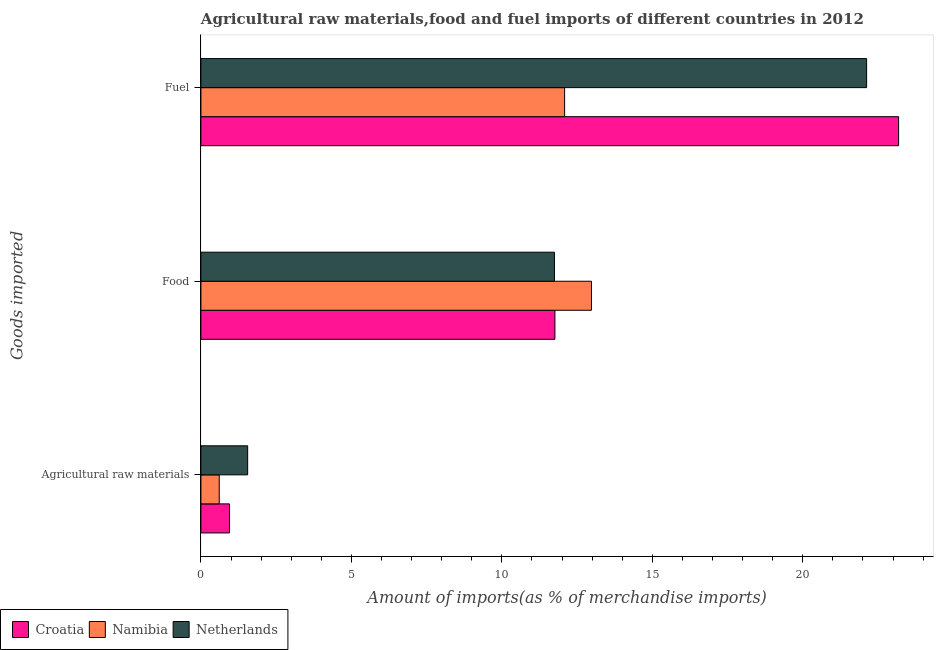How many different coloured bars are there?
Your answer should be very brief. 3. How many groups of bars are there?
Provide a succinct answer. 3. How many bars are there on the 3rd tick from the bottom?
Your response must be concise. 3. What is the label of the 1st group of bars from the top?
Provide a succinct answer. Fuel. What is the percentage of raw materials imports in Croatia?
Your answer should be compact. 0.95. Across all countries, what is the maximum percentage of food imports?
Ensure brevity in your answer.  12.98. Across all countries, what is the minimum percentage of fuel imports?
Keep it short and to the point. 12.09. In which country was the percentage of food imports maximum?
Your response must be concise. Namibia. In which country was the percentage of fuel imports minimum?
Ensure brevity in your answer.  Namibia. What is the total percentage of fuel imports in the graph?
Keep it short and to the point. 57.39. What is the difference between the percentage of fuel imports in Namibia and that in Croatia?
Your answer should be very brief. -11.1. What is the difference between the percentage of fuel imports in Croatia and the percentage of raw materials imports in Netherlands?
Your answer should be compact. 21.63. What is the average percentage of fuel imports per country?
Provide a succinct answer. 19.13. What is the difference between the percentage of food imports and percentage of fuel imports in Netherlands?
Your answer should be compact. -10.37. What is the ratio of the percentage of fuel imports in Namibia to that in Croatia?
Provide a succinct answer. 0.52. Is the percentage of raw materials imports in Namibia less than that in Croatia?
Your answer should be very brief. Yes. What is the difference between the highest and the second highest percentage of food imports?
Provide a short and direct response. 1.21. What is the difference between the highest and the lowest percentage of raw materials imports?
Provide a short and direct response. 0.94. In how many countries, is the percentage of fuel imports greater than the average percentage of fuel imports taken over all countries?
Make the answer very short. 2. Is the sum of the percentage of fuel imports in Croatia and Netherlands greater than the maximum percentage of food imports across all countries?
Offer a terse response. Yes. What does the 2nd bar from the top in Agricultural raw materials represents?
Ensure brevity in your answer.  Namibia. What does the 2nd bar from the bottom in Agricultural raw materials represents?
Offer a terse response. Namibia. Is it the case that in every country, the sum of the percentage of raw materials imports and percentage of food imports is greater than the percentage of fuel imports?
Provide a short and direct response. No. How many bars are there?
Make the answer very short. 9. What is the difference between two consecutive major ticks on the X-axis?
Give a very brief answer. 5. Are the values on the major ticks of X-axis written in scientific E-notation?
Provide a short and direct response. No. Does the graph contain grids?
Offer a terse response. No. Where does the legend appear in the graph?
Offer a terse response. Bottom left. How many legend labels are there?
Your answer should be compact. 3. What is the title of the graph?
Make the answer very short. Agricultural raw materials,food and fuel imports of different countries in 2012. What is the label or title of the X-axis?
Your response must be concise. Amount of imports(as % of merchandise imports). What is the label or title of the Y-axis?
Provide a short and direct response. Goods imported. What is the Amount of imports(as % of merchandise imports) in Croatia in Agricultural raw materials?
Ensure brevity in your answer.  0.95. What is the Amount of imports(as % of merchandise imports) of Namibia in Agricultural raw materials?
Provide a succinct answer. 0.61. What is the Amount of imports(as % of merchandise imports) in Netherlands in Agricultural raw materials?
Offer a terse response. 1.55. What is the Amount of imports(as % of merchandise imports) in Croatia in Food?
Keep it short and to the point. 11.76. What is the Amount of imports(as % of merchandise imports) in Namibia in Food?
Your answer should be compact. 12.98. What is the Amount of imports(as % of merchandise imports) of Netherlands in Food?
Ensure brevity in your answer.  11.75. What is the Amount of imports(as % of merchandise imports) of Croatia in Fuel?
Ensure brevity in your answer.  23.18. What is the Amount of imports(as % of merchandise imports) in Namibia in Fuel?
Offer a terse response. 12.09. What is the Amount of imports(as % of merchandise imports) in Netherlands in Fuel?
Give a very brief answer. 22.12. Across all Goods imported, what is the maximum Amount of imports(as % of merchandise imports) of Croatia?
Offer a very short reply. 23.18. Across all Goods imported, what is the maximum Amount of imports(as % of merchandise imports) in Namibia?
Provide a succinct answer. 12.98. Across all Goods imported, what is the maximum Amount of imports(as % of merchandise imports) in Netherlands?
Offer a very short reply. 22.12. Across all Goods imported, what is the minimum Amount of imports(as % of merchandise imports) of Croatia?
Keep it short and to the point. 0.95. Across all Goods imported, what is the minimum Amount of imports(as % of merchandise imports) in Namibia?
Offer a terse response. 0.61. Across all Goods imported, what is the minimum Amount of imports(as % of merchandise imports) of Netherlands?
Offer a very short reply. 1.55. What is the total Amount of imports(as % of merchandise imports) of Croatia in the graph?
Provide a succinct answer. 35.9. What is the total Amount of imports(as % of merchandise imports) in Namibia in the graph?
Make the answer very short. 25.67. What is the total Amount of imports(as % of merchandise imports) of Netherlands in the graph?
Offer a very short reply. 35.42. What is the difference between the Amount of imports(as % of merchandise imports) in Croatia in Agricultural raw materials and that in Food?
Your response must be concise. -10.81. What is the difference between the Amount of imports(as % of merchandise imports) of Namibia in Agricultural raw materials and that in Food?
Provide a short and direct response. -12.37. What is the difference between the Amount of imports(as % of merchandise imports) in Netherlands in Agricultural raw materials and that in Food?
Keep it short and to the point. -10.19. What is the difference between the Amount of imports(as % of merchandise imports) in Croatia in Agricultural raw materials and that in Fuel?
Provide a short and direct response. -22.23. What is the difference between the Amount of imports(as % of merchandise imports) of Namibia in Agricultural raw materials and that in Fuel?
Keep it short and to the point. -11.48. What is the difference between the Amount of imports(as % of merchandise imports) in Netherlands in Agricultural raw materials and that in Fuel?
Give a very brief answer. -20.57. What is the difference between the Amount of imports(as % of merchandise imports) of Croatia in Food and that in Fuel?
Provide a succinct answer. -11.42. What is the difference between the Amount of imports(as % of merchandise imports) in Namibia in Food and that in Fuel?
Your answer should be compact. 0.89. What is the difference between the Amount of imports(as % of merchandise imports) of Netherlands in Food and that in Fuel?
Provide a succinct answer. -10.37. What is the difference between the Amount of imports(as % of merchandise imports) of Croatia in Agricultural raw materials and the Amount of imports(as % of merchandise imports) of Namibia in Food?
Provide a succinct answer. -12.03. What is the difference between the Amount of imports(as % of merchandise imports) of Croatia in Agricultural raw materials and the Amount of imports(as % of merchandise imports) of Netherlands in Food?
Keep it short and to the point. -10.8. What is the difference between the Amount of imports(as % of merchandise imports) in Namibia in Agricultural raw materials and the Amount of imports(as % of merchandise imports) in Netherlands in Food?
Offer a terse response. -11.14. What is the difference between the Amount of imports(as % of merchandise imports) of Croatia in Agricultural raw materials and the Amount of imports(as % of merchandise imports) of Namibia in Fuel?
Offer a terse response. -11.13. What is the difference between the Amount of imports(as % of merchandise imports) in Croatia in Agricultural raw materials and the Amount of imports(as % of merchandise imports) in Netherlands in Fuel?
Provide a short and direct response. -21.17. What is the difference between the Amount of imports(as % of merchandise imports) of Namibia in Agricultural raw materials and the Amount of imports(as % of merchandise imports) of Netherlands in Fuel?
Offer a very short reply. -21.51. What is the difference between the Amount of imports(as % of merchandise imports) of Croatia in Food and the Amount of imports(as % of merchandise imports) of Namibia in Fuel?
Offer a very short reply. -0.32. What is the difference between the Amount of imports(as % of merchandise imports) in Croatia in Food and the Amount of imports(as % of merchandise imports) in Netherlands in Fuel?
Your response must be concise. -10.36. What is the difference between the Amount of imports(as % of merchandise imports) of Namibia in Food and the Amount of imports(as % of merchandise imports) of Netherlands in Fuel?
Offer a terse response. -9.14. What is the average Amount of imports(as % of merchandise imports) in Croatia per Goods imported?
Give a very brief answer. 11.97. What is the average Amount of imports(as % of merchandise imports) of Namibia per Goods imported?
Make the answer very short. 8.56. What is the average Amount of imports(as % of merchandise imports) of Netherlands per Goods imported?
Your answer should be very brief. 11.81. What is the difference between the Amount of imports(as % of merchandise imports) of Croatia and Amount of imports(as % of merchandise imports) of Namibia in Agricultural raw materials?
Give a very brief answer. 0.34. What is the difference between the Amount of imports(as % of merchandise imports) of Croatia and Amount of imports(as % of merchandise imports) of Netherlands in Agricultural raw materials?
Your answer should be compact. -0.6. What is the difference between the Amount of imports(as % of merchandise imports) in Namibia and Amount of imports(as % of merchandise imports) in Netherlands in Agricultural raw materials?
Provide a short and direct response. -0.94. What is the difference between the Amount of imports(as % of merchandise imports) of Croatia and Amount of imports(as % of merchandise imports) of Namibia in Food?
Your response must be concise. -1.21. What is the difference between the Amount of imports(as % of merchandise imports) of Croatia and Amount of imports(as % of merchandise imports) of Netherlands in Food?
Offer a terse response. 0.02. What is the difference between the Amount of imports(as % of merchandise imports) in Namibia and Amount of imports(as % of merchandise imports) in Netherlands in Food?
Provide a succinct answer. 1.23. What is the difference between the Amount of imports(as % of merchandise imports) of Croatia and Amount of imports(as % of merchandise imports) of Namibia in Fuel?
Your answer should be compact. 11.1. What is the difference between the Amount of imports(as % of merchandise imports) in Croatia and Amount of imports(as % of merchandise imports) in Netherlands in Fuel?
Provide a short and direct response. 1.06. What is the difference between the Amount of imports(as % of merchandise imports) of Namibia and Amount of imports(as % of merchandise imports) of Netherlands in Fuel?
Your response must be concise. -10.04. What is the ratio of the Amount of imports(as % of merchandise imports) in Croatia in Agricultural raw materials to that in Food?
Offer a terse response. 0.08. What is the ratio of the Amount of imports(as % of merchandise imports) in Namibia in Agricultural raw materials to that in Food?
Offer a very short reply. 0.05. What is the ratio of the Amount of imports(as % of merchandise imports) of Netherlands in Agricultural raw materials to that in Food?
Provide a succinct answer. 0.13. What is the ratio of the Amount of imports(as % of merchandise imports) of Croatia in Agricultural raw materials to that in Fuel?
Make the answer very short. 0.04. What is the ratio of the Amount of imports(as % of merchandise imports) in Namibia in Agricultural raw materials to that in Fuel?
Your answer should be very brief. 0.05. What is the ratio of the Amount of imports(as % of merchandise imports) of Netherlands in Agricultural raw materials to that in Fuel?
Ensure brevity in your answer.  0.07. What is the ratio of the Amount of imports(as % of merchandise imports) in Croatia in Food to that in Fuel?
Give a very brief answer. 0.51. What is the ratio of the Amount of imports(as % of merchandise imports) of Namibia in Food to that in Fuel?
Your answer should be compact. 1.07. What is the ratio of the Amount of imports(as % of merchandise imports) of Netherlands in Food to that in Fuel?
Provide a short and direct response. 0.53. What is the difference between the highest and the second highest Amount of imports(as % of merchandise imports) in Croatia?
Provide a short and direct response. 11.42. What is the difference between the highest and the second highest Amount of imports(as % of merchandise imports) in Namibia?
Provide a short and direct response. 0.89. What is the difference between the highest and the second highest Amount of imports(as % of merchandise imports) of Netherlands?
Your answer should be compact. 10.37. What is the difference between the highest and the lowest Amount of imports(as % of merchandise imports) in Croatia?
Your answer should be very brief. 22.23. What is the difference between the highest and the lowest Amount of imports(as % of merchandise imports) of Namibia?
Your answer should be compact. 12.37. What is the difference between the highest and the lowest Amount of imports(as % of merchandise imports) in Netherlands?
Keep it short and to the point. 20.57. 